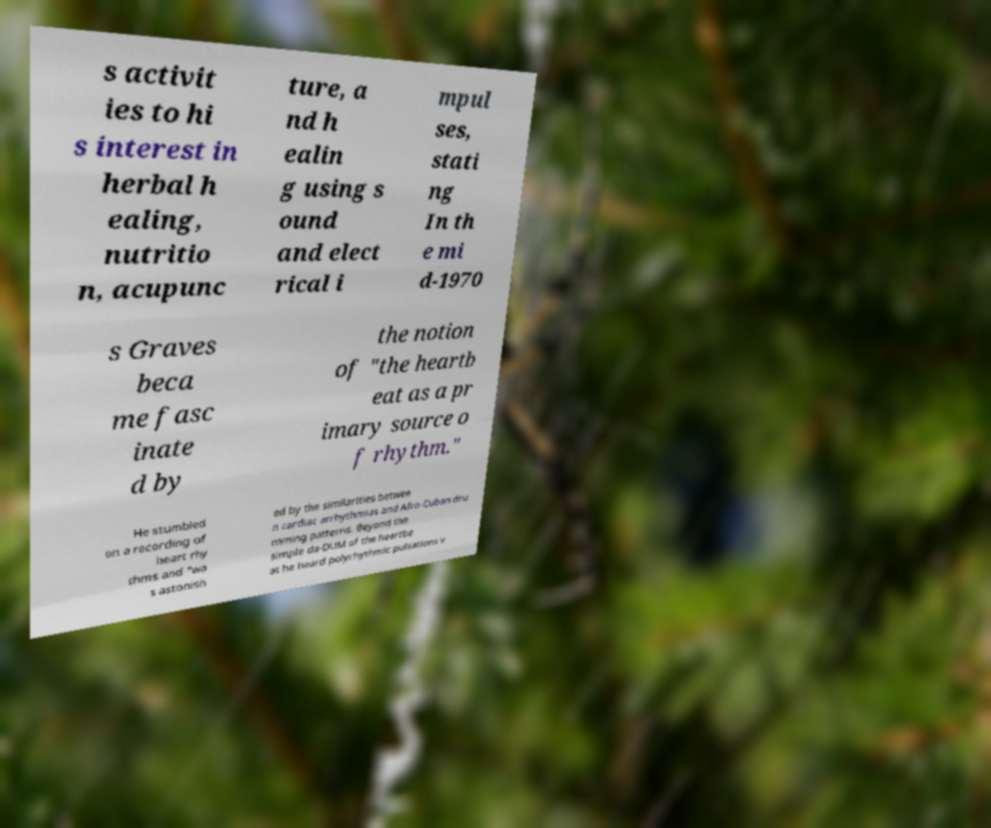Could you extract and type out the text from this image? s activit ies to hi s interest in herbal h ealing, nutritio n, acupunc ture, a nd h ealin g using s ound and elect rical i mpul ses, stati ng In th e mi d-1970 s Graves beca me fasc inate d by the notion of "the heartb eat as a pr imary source o f rhythm." He stumbled on a recording of heart rhy thms and "wa s astonish ed by the similarities betwee n cardiac arrhythmias and Afro-Cuban dru mming patterns. Beyond the simple da-DUM of the heartbe at he heard polyrhythmic pulsations v 